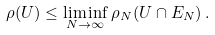<formula> <loc_0><loc_0><loc_500><loc_500>\rho ( U ) \leq \liminf _ { N \rightarrow \infty } \rho _ { N } ( U \cap E _ { N } ) \, .</formula> 